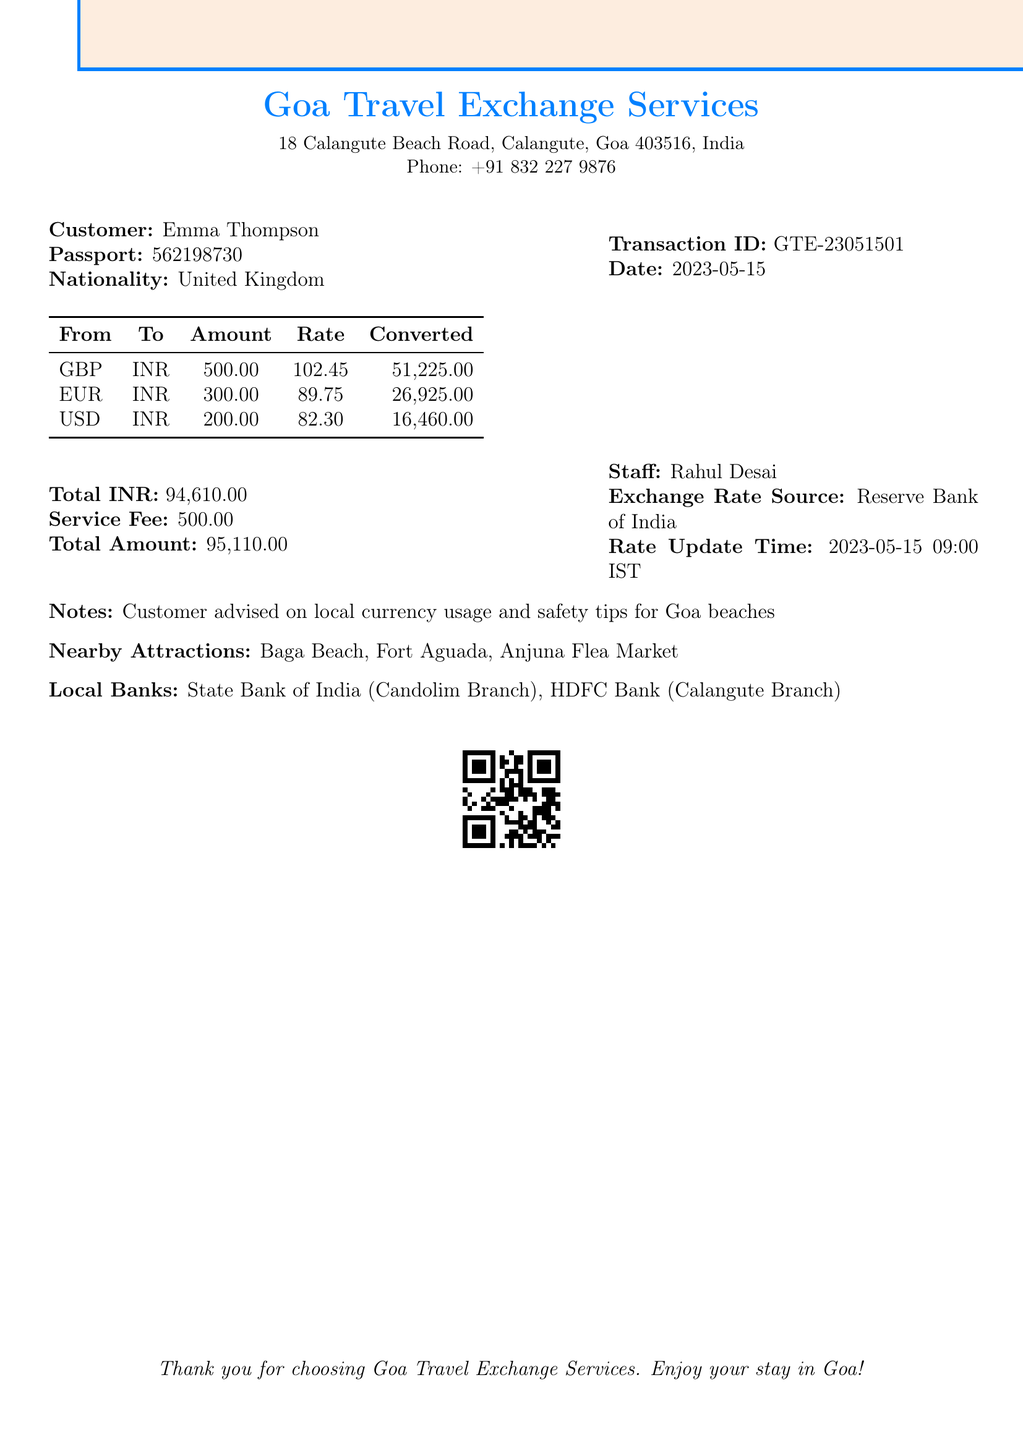What is the name of the customer? The customer's name is explicitly stated in the document as Emma Thompson.
Answer: Emma Thompson What is the transaction ID? The transaction ID is mentioned in the document as GTE-23051501.
Answer: GTE-23051501 What is the total amount after the service fee? The total amount is detailed at the end of the document, including the service fee, which is 95,110.
Answer: 95,110 What currency did the customer exchange from GBP to? The document specifies that GBP was exchanged to INR.
Answer: INR Who is the staff member that assisted the customer? The staff member who assisted is named in the document as Rahul Desai.
Answer: Rahul Desai What is the total amount converted from USD? The total amount converted from USD to INR is provided in the table as 16,460.
Answer: 16,460 What is the exchange rate source mentioned in the document? The source of the exchange rate is explicitly mentioned as the Reserve Bank of India.
Answer: Reserve Bank of India What local banks are listed in the document? The local banks mentioned include State Bank of India (Candolim Branch) and HDFC Bank (Calangute Branch).
Answer: State Bank of India, HDFC Bank What date was the transaction conducted? The date of the transaction is indicated clearly in the document as 2023-05-15.
Answer: 2023-05-15 